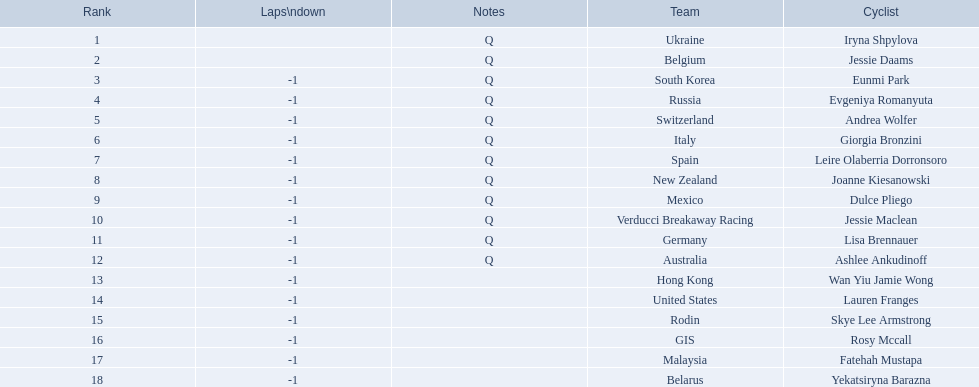Who are all the cyclists? Iryna Shpylova, Jessie Daams, Eunmi Park, Evgeniya Romanyuta, Andrea Wolfer, Giorgia Bronzini, Leire Olaberria Dorronsoro, Joanne Kiesanowski, Dulce Pliego, Jessie Maclean, Lisa Brennauer, Ashlee Ankudinoff, Wan Yiu Jamie Wong, Lauren Franges, Skye Lee Armstrong, Rosy Mccall, Fatehah Mustapa, Yekatsiryna Barazna. What were their ranks? 1, 2, 3, 4, 5, 6, 7, 8, 9, 10, 11, 12, 13, 14, 15, 16, 17, 18. Who was ranked highest? Iryna Shpylova. 